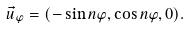Convert formula to latex. <formula><loc_0><loc_0><loc_500><loc_500>\vec { u } _ { \varphi } = ( - \sin n \varphi , \cos n \varphi , 0 ) .</formula> 